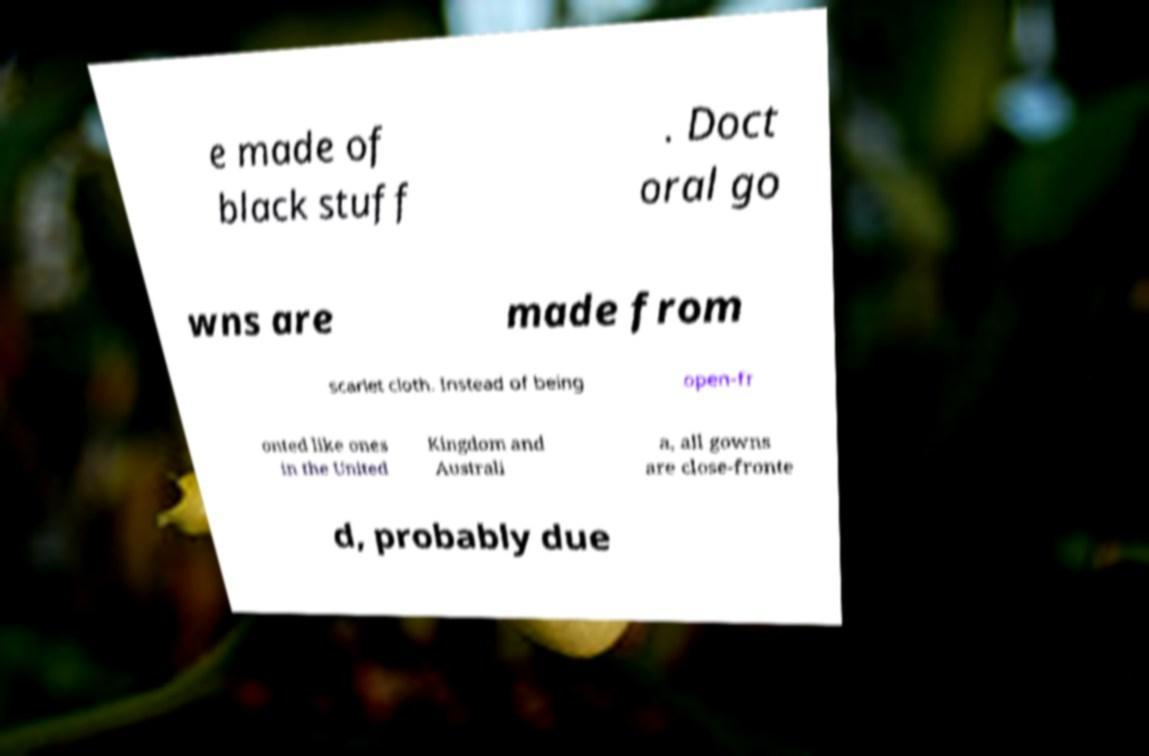There's text embedded in this image that I need extracted. Can you transcribe it verbatim? e made of black stuff . Doct oral go wns are made from scarlet cloth. Instead of being open-fr onted like ones in the United Kingdom and Australi a, all gowns are close-fronte d, probably due 